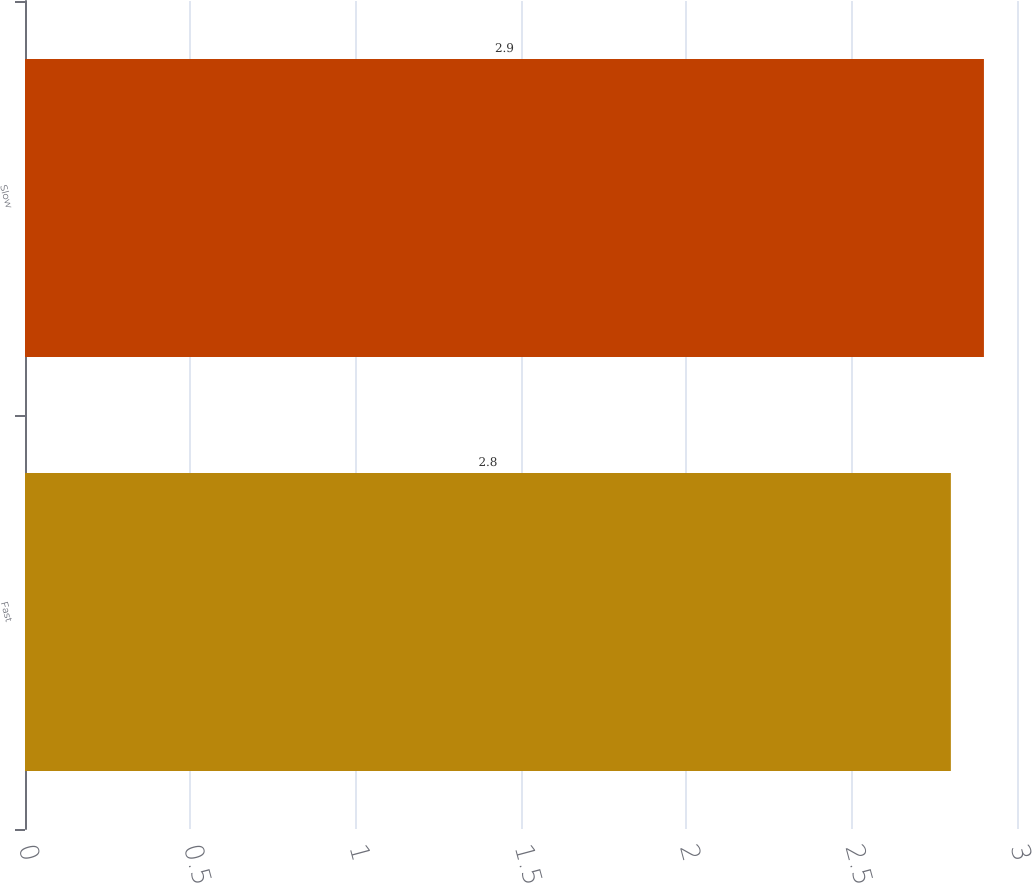Convert chart to OTSL. <chart><loc_0><loc_0><loc_500><loc_500><bar_chart><fcel>Fast<fcel>Slow<nl><fcel>2.8<fcel>2.9<nl></chart> 